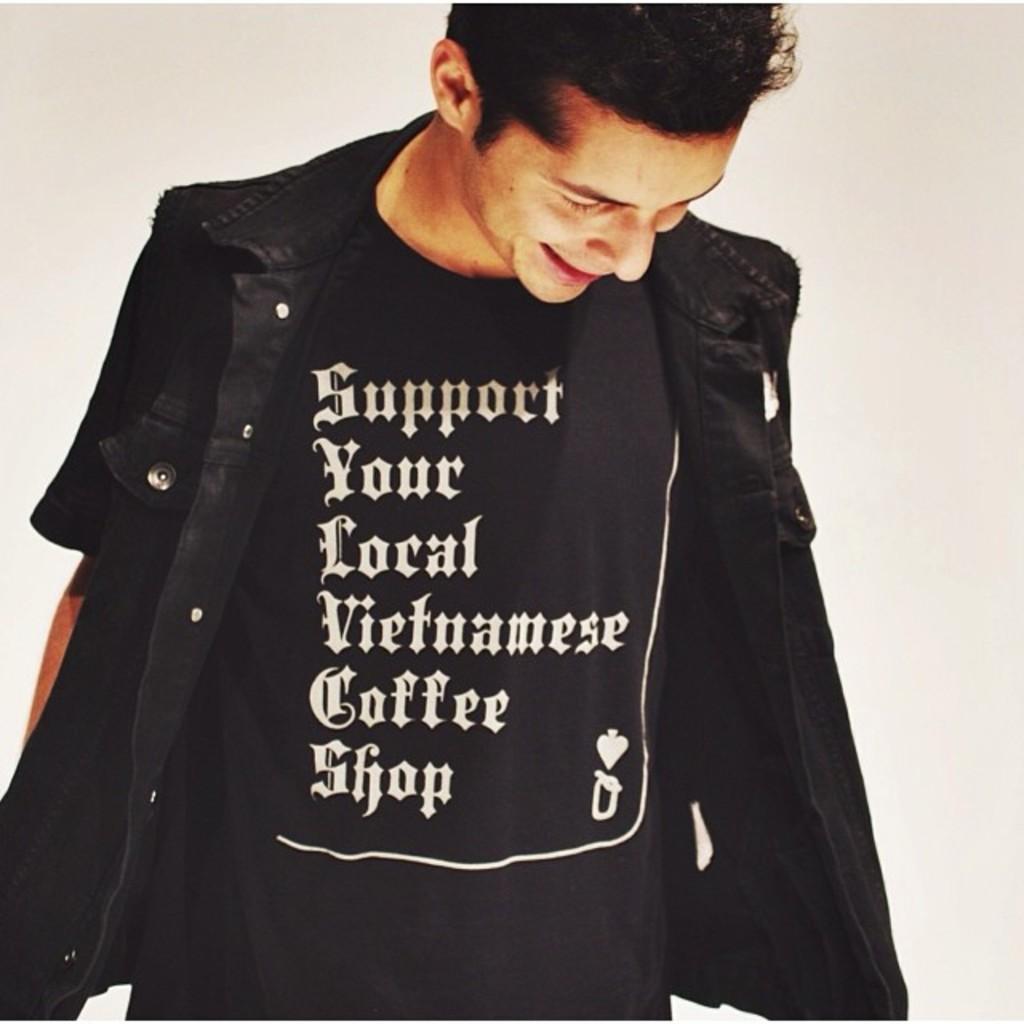Please provide a concise description of this image. In this picture I can see a man standing and a white color background and I can see text on his t-shirt. 